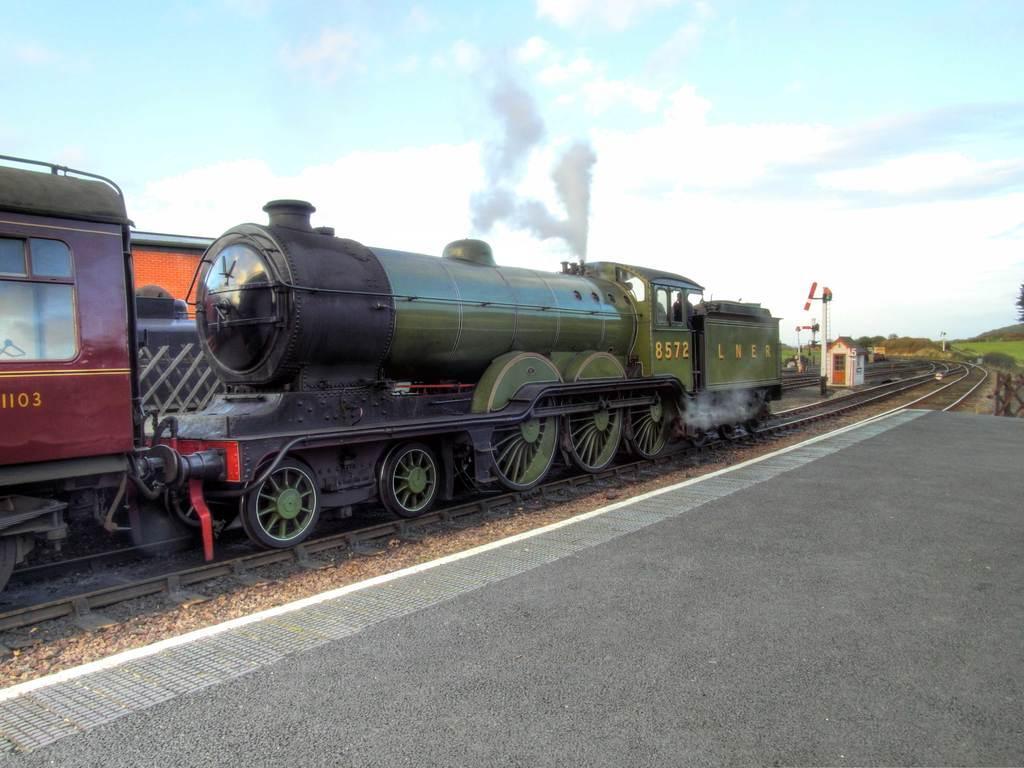Can you describe this image briefly? In this image I can see the road, few railway tracks on the ground, a small shed, few poles and a train which is green, black and maroon in color on the track. In the background I can see the sky. 